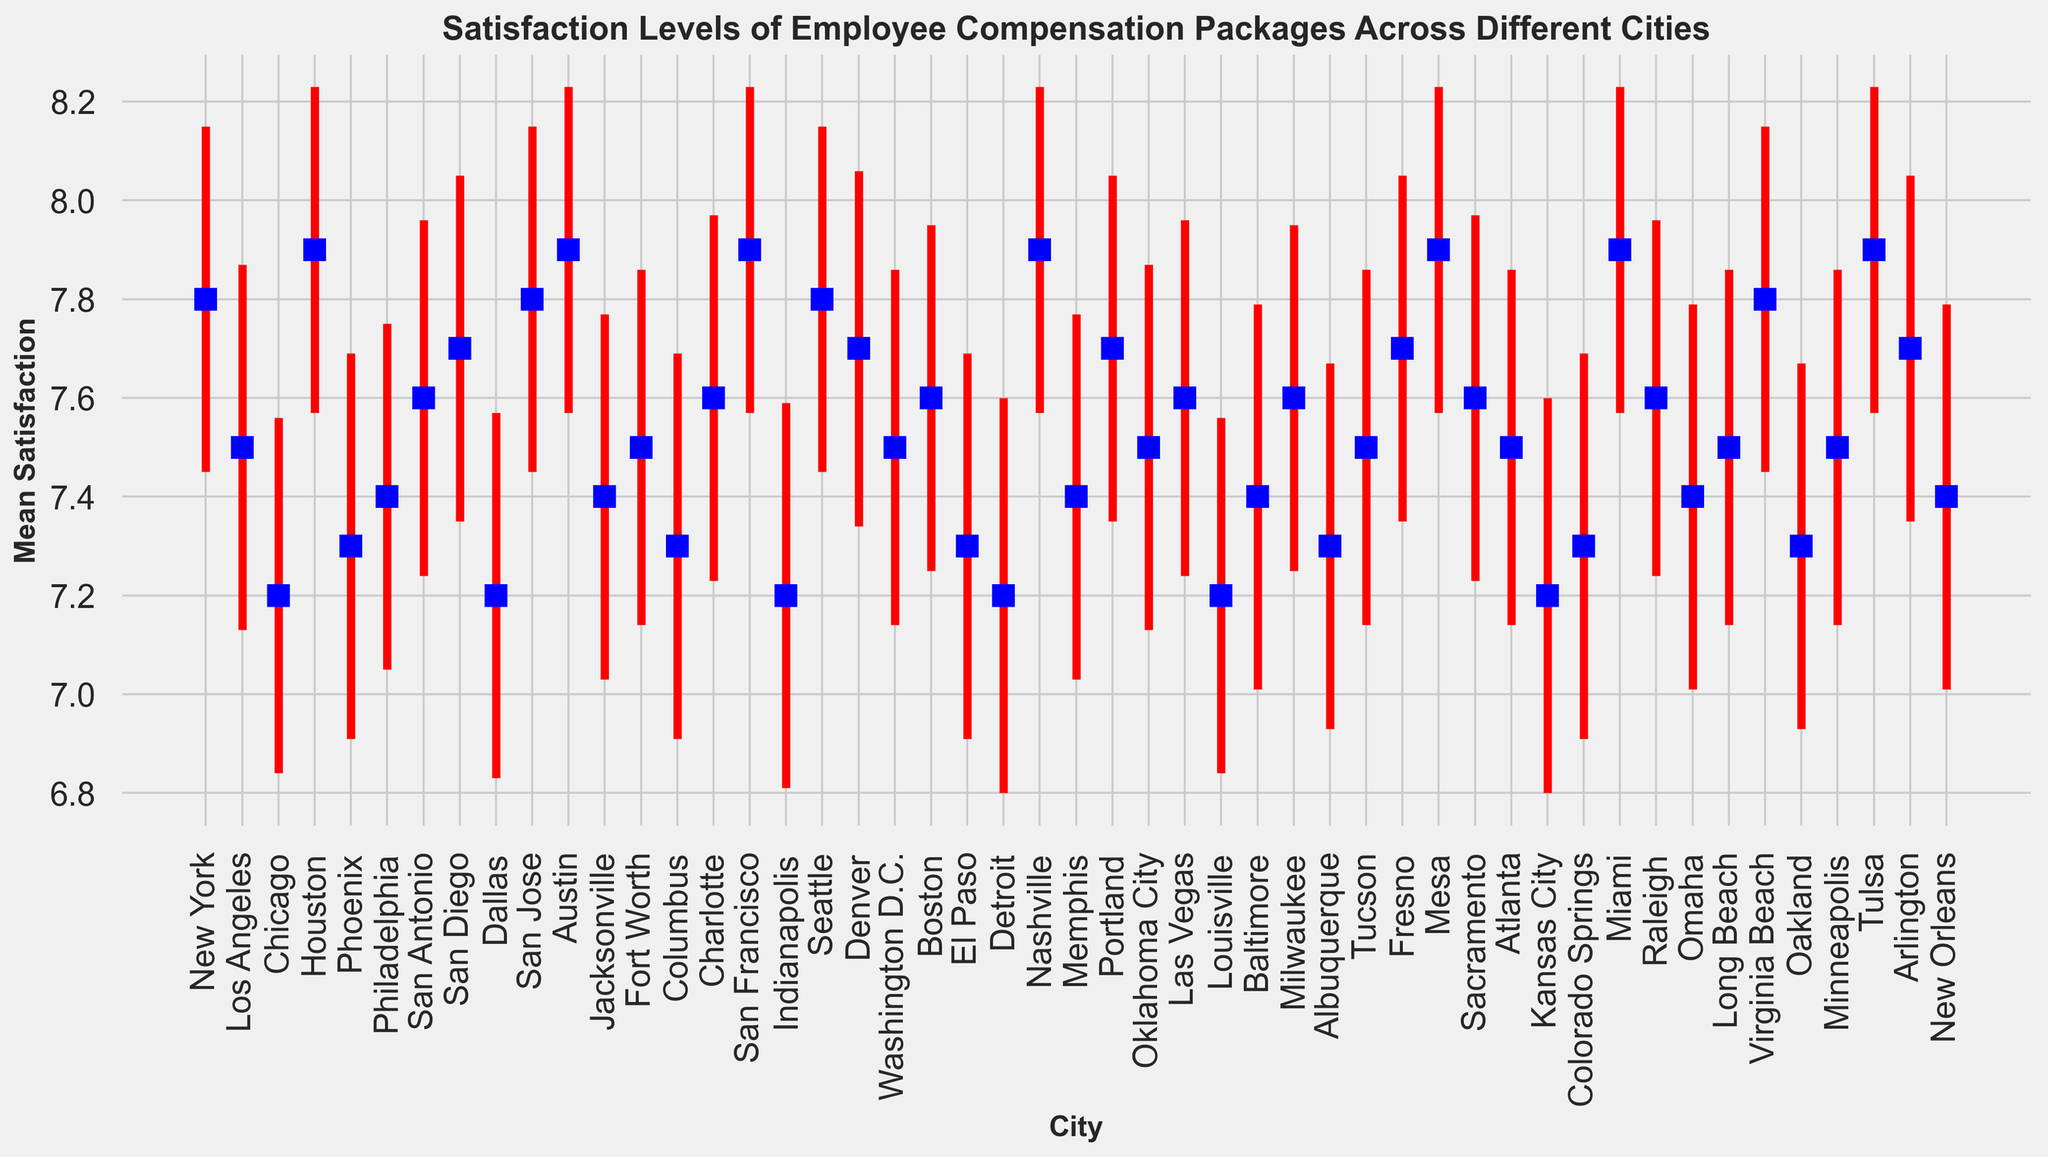What city has the highest mean satisfaction level? Looking at the figure, identify the city with the highest point on the vertical axis representing mean satisfaction.
Answer: Houston, Austin, San Francisco, Nashville, Miami, Tulsa, Mesa Which city has the lowest mean satisfaction level? Identify the city with the lowest point on the vertical axis representing mean satisfaction.
Answer: Chicago, Dallas, Indianapolis, Detroit, Kansas City, Louisville What is the range of mean satisfaction levels across all cities? To calculate the range, subtract the lowest mean satisfaction value from the highest mean satisfaction value.
Answer: 7.9 - 7.2 = 0.7 Which cities have a mean satisfaction level of 7.5? Identify all cities that have a point on the vertical axis corresponding to a mean satisfaction value of 7.5.
Answer: Los Angeles, Washington D.C., Oklahoma City, Long Beach, Minneapolis, Atlanta What is the average mean satisfaction level of all the cities? Sum all the mean satisfaction levels and then divide by the number of cities.
Answer: (Sum of all mean satisfaction levels) / 50 Which city has the smallest standard error? Identify the city with the shortest error bar, as standard error is visually represented by the height of the error bar.
Answer: Houston, Austin, San Francisco, Nashville, Miami, Tulsa, Mesa Are there cities where the mean satisfaction is equal to the highest mean satisfaction minus the standard error? Check if there are cities where mean satisfaction level equals 7.9 - 0.33
Answer: No Which city has the largest variance? Identify the city with the largest associated variance from the data.
Answer: Detroit and Kansas City What percentage of cities have a mean satisfaction level of 7.5 or higher? Count the number of cities with a mean satisfaction level of 7.5 or higher, then divide by the total number of cities and multiply by 100.
Answer: (Number of cities with mean satisfaction >= 7.5) / 50 * 100 Which city has the highest combined value of mean satisfaction and standard error? Add the mean satisfaction level and standard error for each city and identify the highest sum.
Answer: Phoenix 